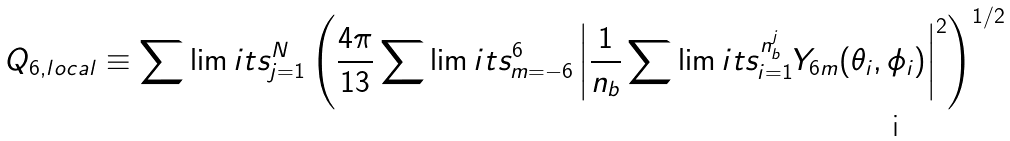<formula> <loc_0><loc_0><loc_500><loc_500>Q _ { 6 , l o c a l } \equiv \sum \lim i t s _ { j = 1 } ^ { N } \left ( \frac { 4 \pi } { 1 3 } \sum \lim i t s _ { m = - 6 } ^ { 6 } \left | \frac { 1 } { n _ { b } } \sum \lim i t s _ { i = 1 } ^ { n _ { b } ^ { j } } Y _ { 6 m } ( \theta _ { i } , \phi _ { i } ) \right | ^ { 2 } \right ) ^ { 1 / 2 }</formula> 